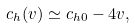Convert formula to latex. <formula><loc_0><loc_0><loc_500><loc_500>c _ { h } ( v ) \simeq c _ { h 0 } - 4 v ,</formula> 